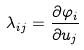<formula> <loc_0><loc_0><loc_500><loc_500>\lambda _ { i j } = \frac { \partial \varphi _ { i } } { \partial u _ { j } }</formula> 